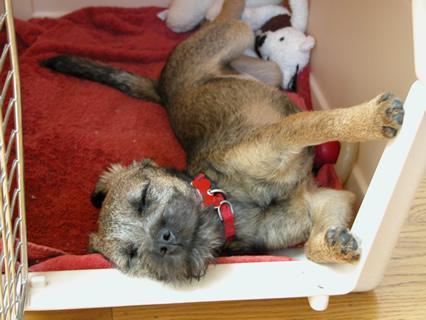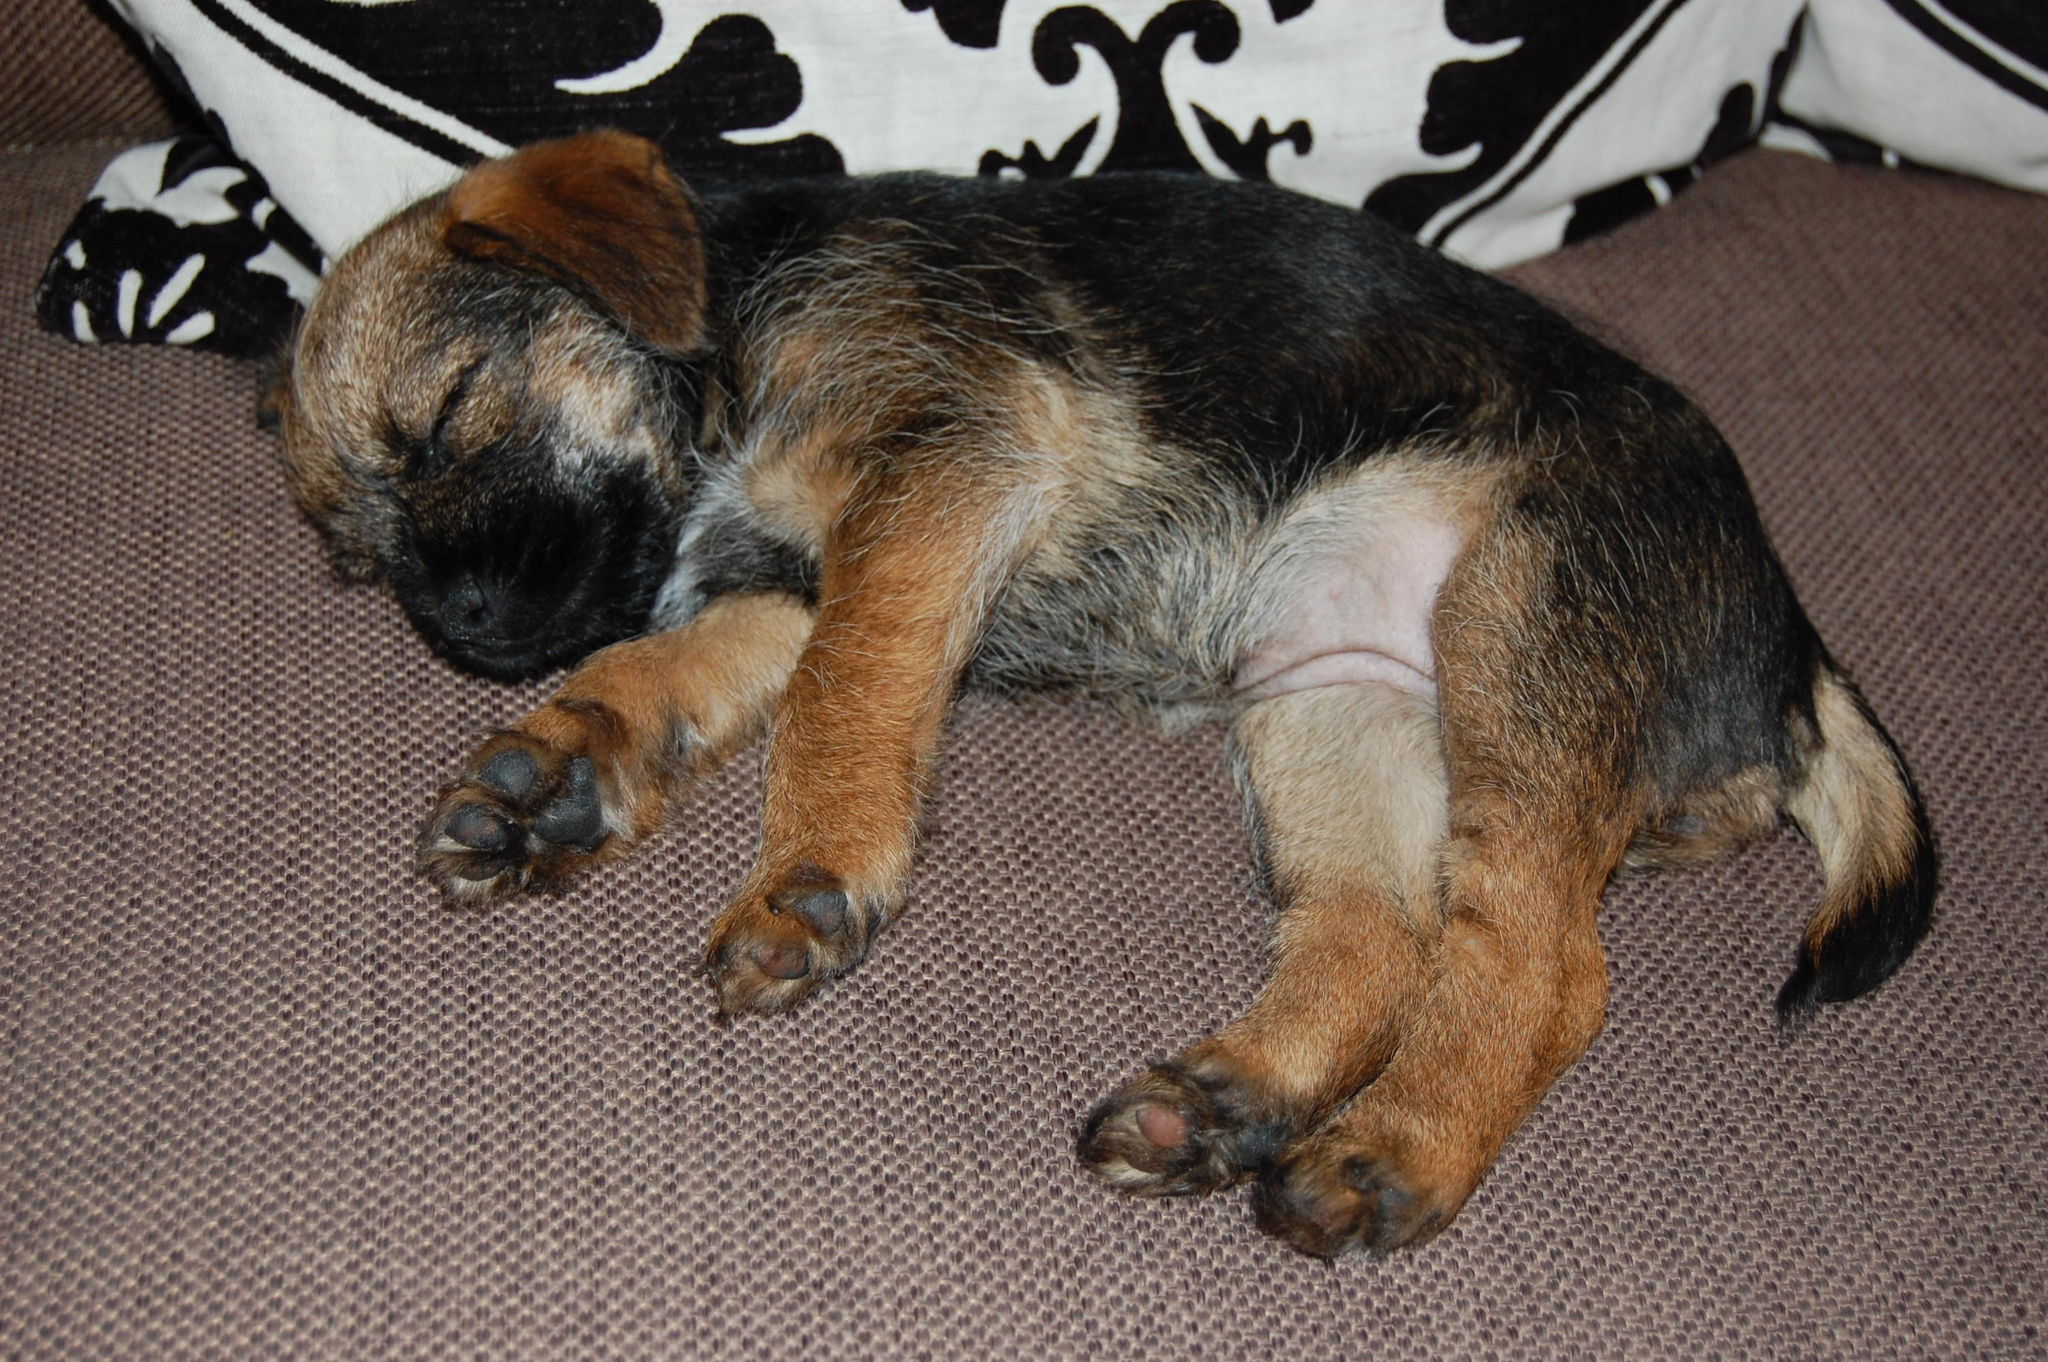The first image is the image on the left, the second image is the image on the right. Examine the images to the left and right. Is the description "There are three dogs sleeping" accurate? Answer yes or no. No. The first image is the image on the left, the second image is the image on the right. Considering the images on both sides, is "There are no more than two dogs." valid? Answer yes or no. Yes. 